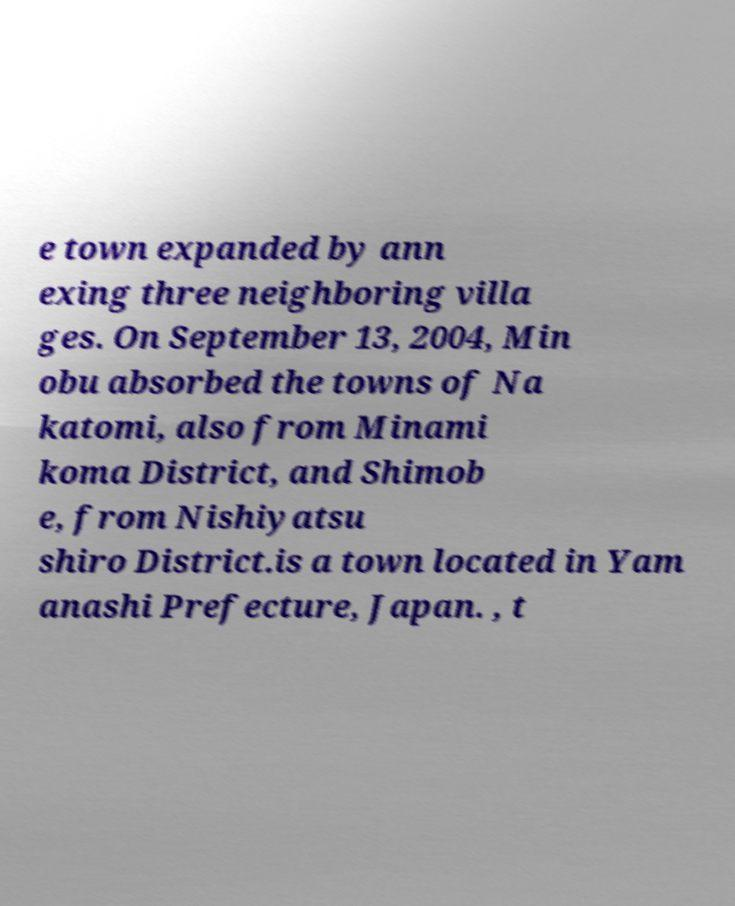Please identify and transcribe the text found in this image. e town expanded by ann exing three neighboring villa ges. On September 13, 2004, Min obu absorbed the towns of Na katomi, also from Minami koma District, and Shimob e, from Nishiyatsu shiro District.is a town located in Yam anashi Prefecture, Japan. , t 